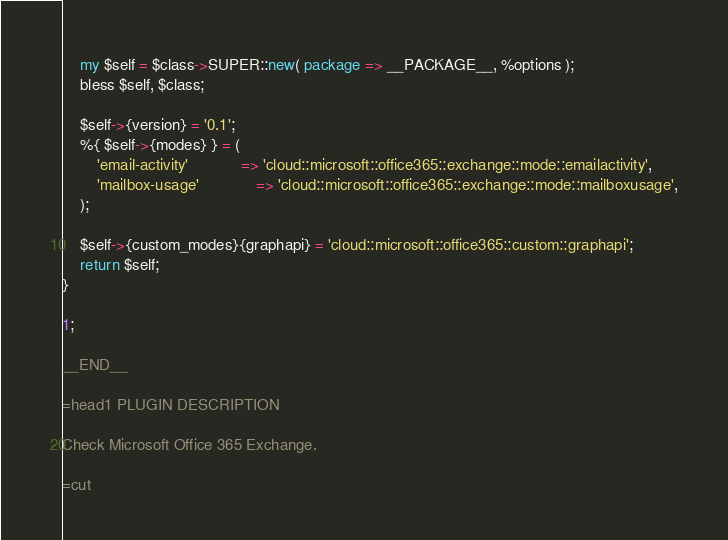<code> <loc_0><loc_0><loc_500><loc_500><_Perl_>    my $self = $class->SUPER::new( package => __PACKAGE__, %options );
    bless $self, $class;

    $self->{version} = '0.1';
    %{ $self->{modes} } = (
        'email-activity'            => 'cloud::microsoft::office365::exchange::mode::emailactivity',
        'mailbox-usage'             => 'cloud::microsoft::office365::exchange::mode::mailboxusage',
    );

    $self->{custom_modes}{graphapi} = 'cloud::microsoft::office365::custom::graphapi';
    return $self;
}

1;

__END__

=head1 PLUGIN DESCRIPTION

Check Microsoft Office 365 Exchange.

=cut
</code> 